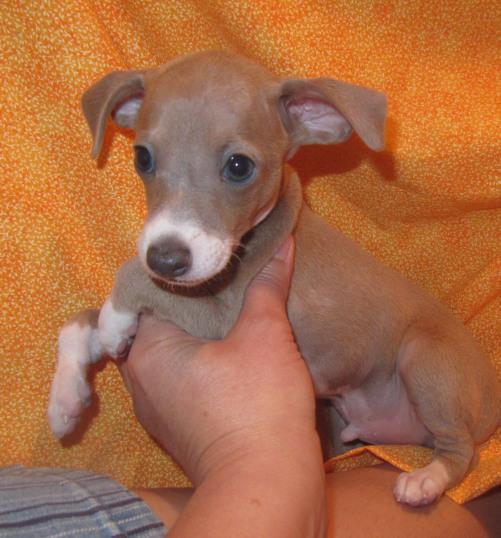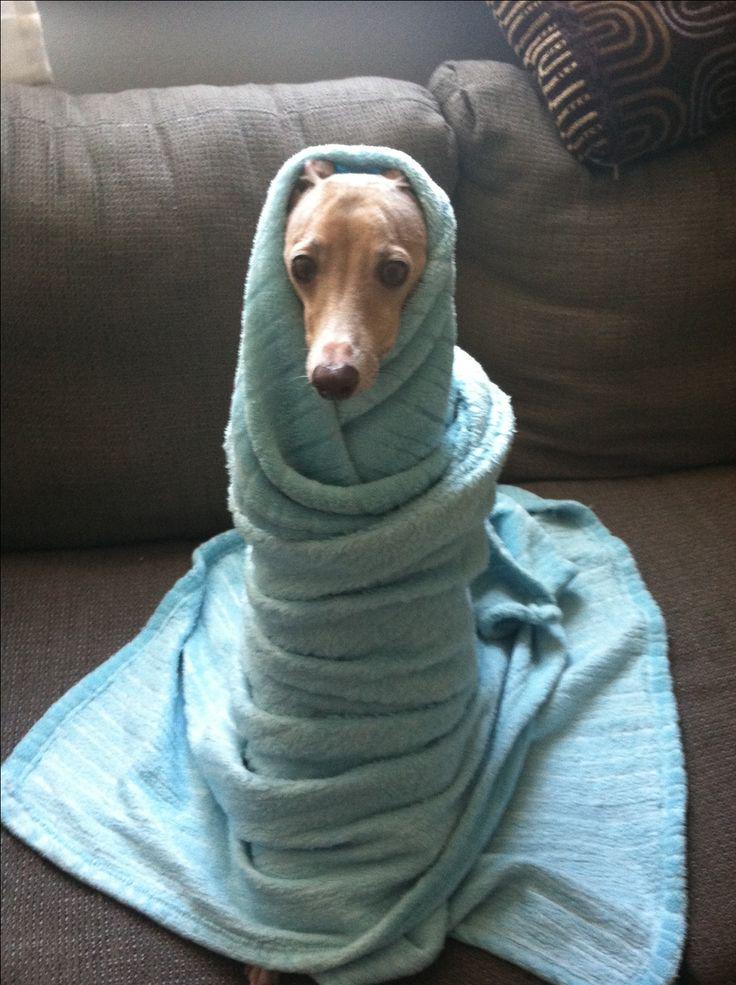The first image is the image on the left, the second image is the image on the right. Assess this claim about the two images: "there is an animal wrapped up in something blue in the image on the right side.". Correct or not? Answer yes or no. Yes. 